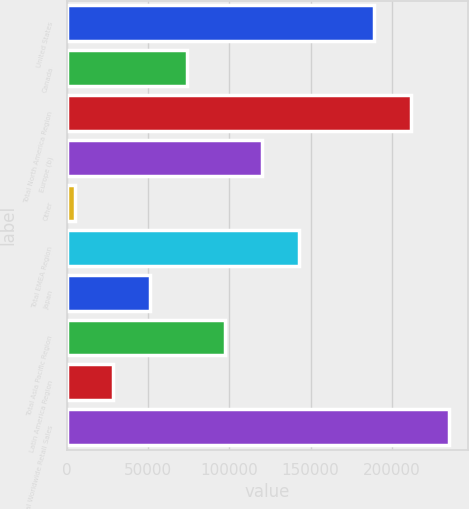Convert chart. <chart><loc_0><loc_0><loc_500><loc_500><bar_chart><fcel>United States<fcel>Canada<fcel>Total North America Region<fcel>Europe (b)<fcel>Other<fcel>Total EMEA Region<fcel>Japan<fcel>Total Asia Pacific Region<fcel>Latin America Region<fcel>Total Worldwide Retail Sales<nl><fcel>189152<fcel>74060.6<fcel>212170<fcel>120097<fcel>5006<fcel>143115<fcel>51042.4<fcel>97078.8<fcel>28024.2<fcel>235188<nl></chart> 